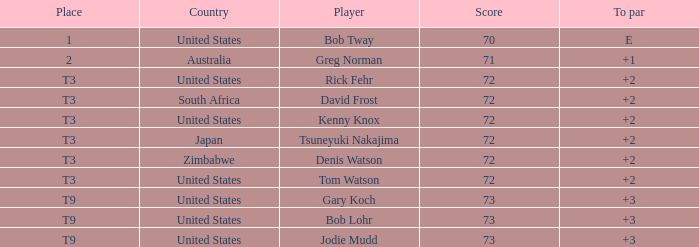Who scored more than 72? Gary Koch, Bob Lohr, Jodie Mudd. 